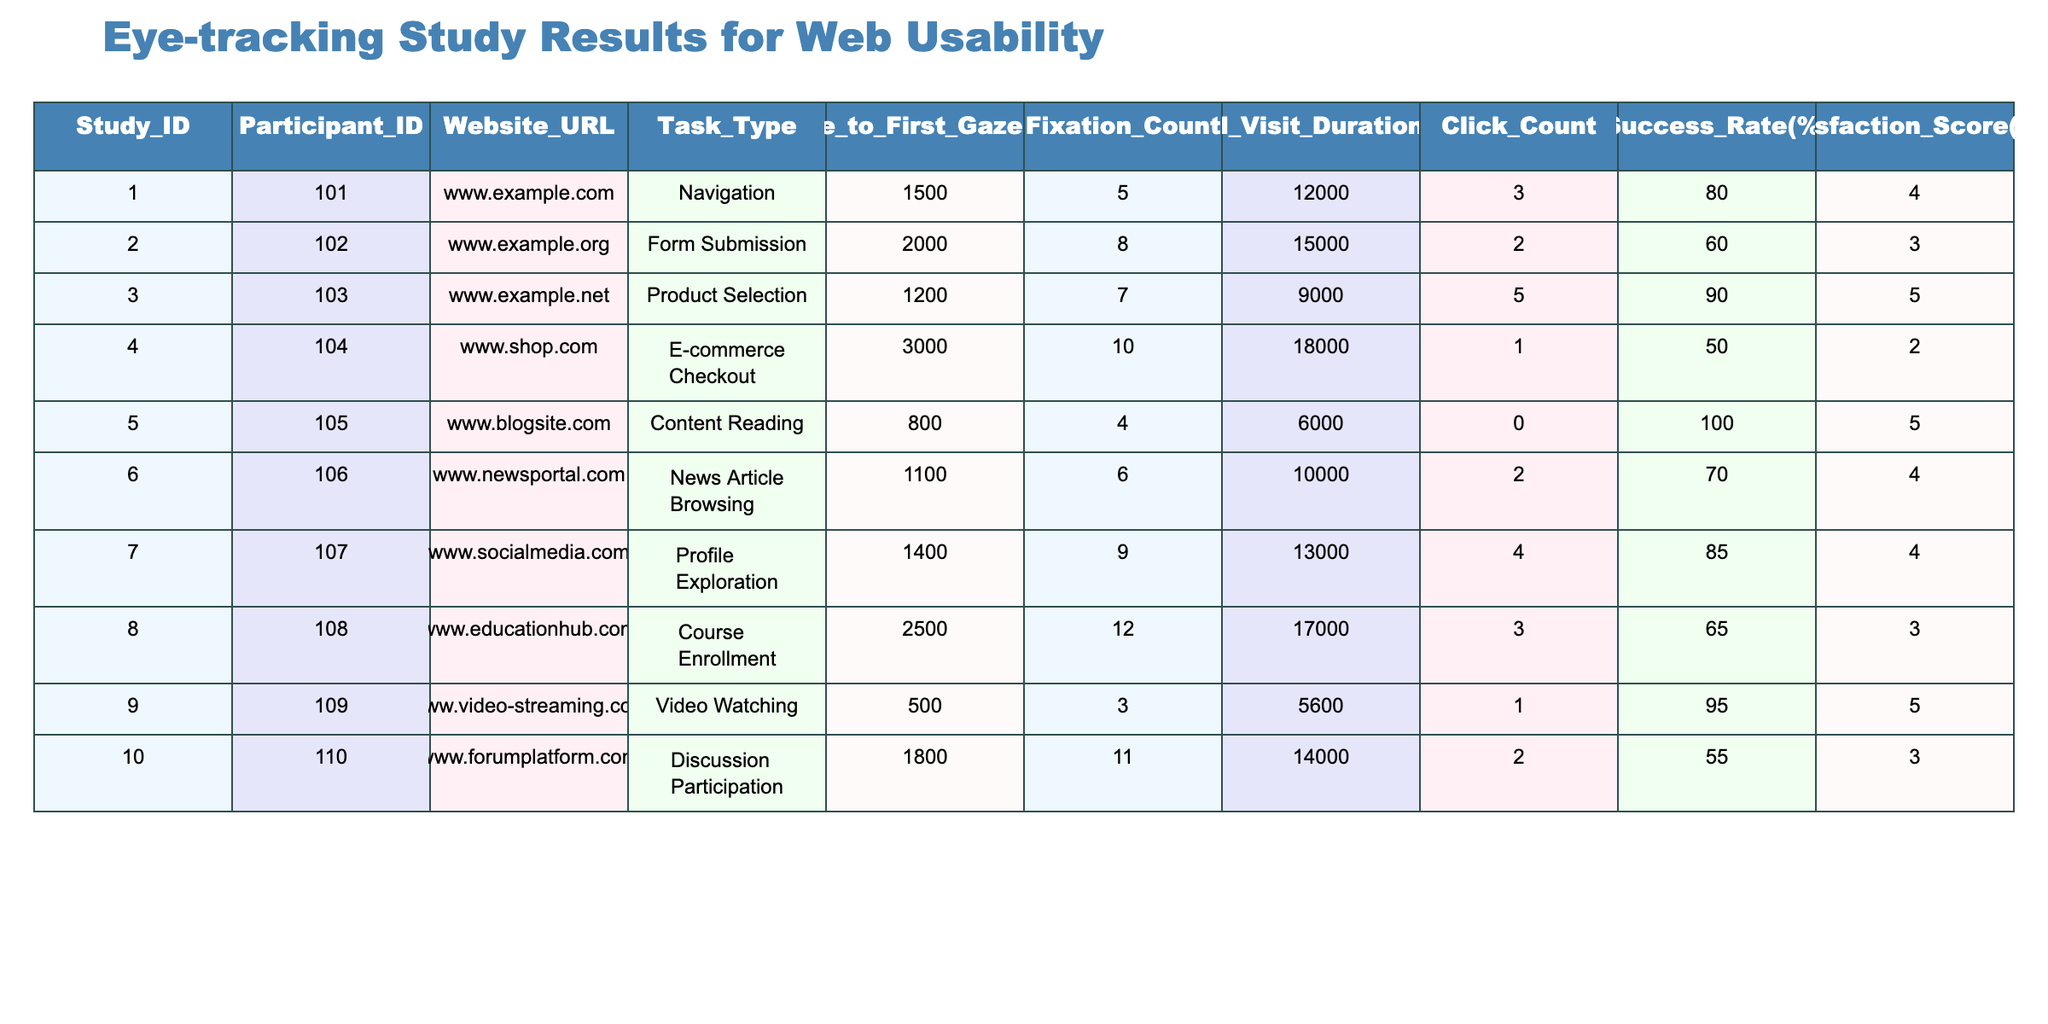What is the success rate for the website www.example.org? The success rate for a particular website can be directly found in the corresponding row of the table. For www.example.org, the success rate is listed as 60%.
Answer: 60% What task type had the highest satisfaction score? To determine the task type with the highest satisfaction score, we look at the Satisfaction Score column and find that the maximum score is 5. The task types with this score are "Product Selection" and "Content Reading."
Answer: Product Selection and Content Reading What is the average time to first gaze across all tasks? To calculate the average time to first gaze, we sum the Time to First Gaze for all tasks: 1500 + 2000 + 1200 + 3000 + 800 + 1100 + 1400 + 2500 + 500 + 1800 = 18600 ms. We then divide by the number of tasks, which is 10, giving us an average of 1860 ms.
Answer: 1860 ms Did any participant achieve a click count of zero? By reviewing the Click Count column, we find that participant 105 has a click count of 0. This indicates that it is true that there is at least one participant with zero clicks.
Answer: Yes What is the difference in total visit duration between the longest and shortest visit durations? To find this difference, we first identify the longest total visit duration, which is 18000 ms (www.shop.com), and the shortest, which is 5600 ms (www.video-streaming.com). The difference is 18000 - 5600 = 12400 ms.
Answer: 12400 ms Which website had the highest fixation count? The highest fixation count can be identified by examining the Fixation Count column. www.educationhub.com has the highest fixation count of 12.
Answer: www.educationhub.com What is the satisfaction score for the task type "E-commerce Checkout"? We look at the Satisfaction Score column and find the corresponding row for "E-commerce Checkout," which shows a satisfaction score of 2.
Answer: 2 Which website had the lowest success rate, and what is that rate? By scanning the Success Rate column, we find that the lowest success rate is 50%, associated with the website www.shop.com.
Answer: www.shop.com, 50% 